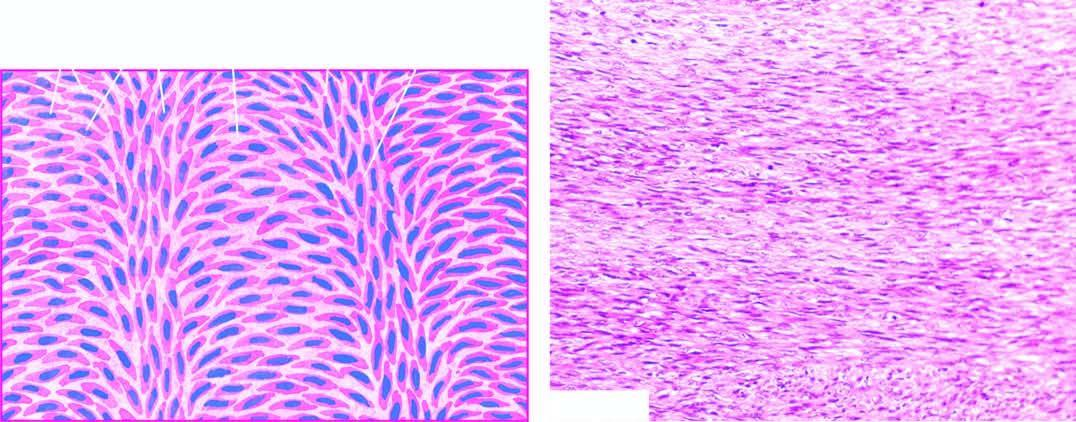what shows a well-differentiated tumour composed of spindle-shaped cells forming interlacing fascicles producing a typical herring-bone pattern?
Answer the question using a single word or phrase. Microscopy 